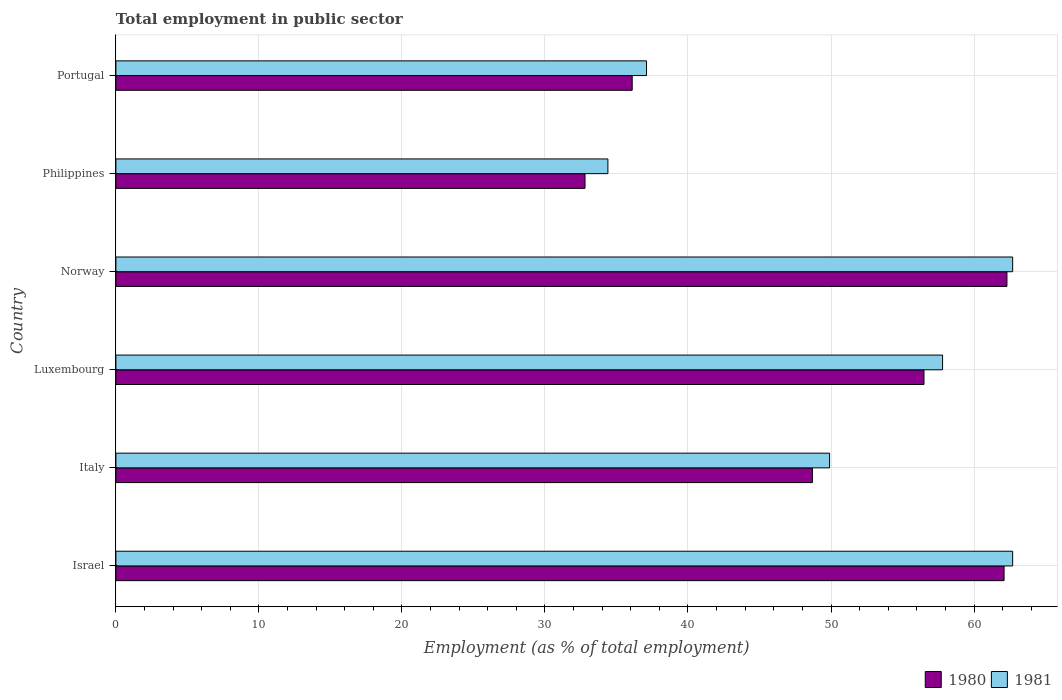Are the number of bars per tick equal to the number of legend labels?
Ensure brevity in your answer.  Yes. Are the number of bars on each tick of the Y-axis equal?
Provide a short and direct response. Yes. How many bars are there on the 5th tick from the bottom?
Give a very brief answer. 2. What is the label of the 3rd group of bars from the top?
Provide a succinct answer. Norway. In how many cases, is the number of bars for a given country not equal to the number of legend labels?
Your answer should be very brief. 0. What is the employment in public sector in 1981 in Norway?
Make the answer very short. 62.7. Across all countries, what is the maximum employment in public sector in 1981?
Your answer should be very brief. 62.7. Across all countries, what is the minimum employment in public sector in 1981?
Offer a terse response. 34.4. In which country was the employment in public sector in 1981 minimum?
Provide a short and direct response. Philippines. What is the total employment in public sector in 1980 in the graph?
Offer a terse response. 298.5. What is the difference between the employment in public sector in 1980 in Israel and that in Norway?
Make the answer very short. -0.2. What is the difference between the employment in public sector in 1981 in Portugal and the employment in public sector in 1980 in Philippines?
Provide a short and direct response. 4.3. What is the average employment in public sector in 1980 per country?
Provide a succinct answer. 49.75. What is the difference between the employment in public sector in 1981 and employment in public sector in 1980 in Luxembourg?
Your answer should be very brief. 1.3. In how many countries, is the employment in public sector in 1981 greater than 14 %?
Your response must be concise. 6. What is the ratio of the employment in public sector in 1981 in Luxembourg to that in Norway?
Provide a short and direct response. 0.92. What is the difference between the highest and the lowest employment in public sector in 1981?
Ensure brevity in your answer.  28.3. In how many countries, is the employment in public sector in 1981 greater than the average employment in public sector in 1981 taken over all countries?
Keep it short and to the point. 3. What does the 2nd bar from the top in Portugal represents?
Provide a short and direct response. 1980. How many countries are there in the graph?
Offer a terse response. 6. Does the graph contain any zero values?
Ensure brevity in your answer.  No. How many legend labels are there?
Your response must be concise. 2. What is the title of the graph?
Offer a terse response. Total employment in public sector. Does "2006" appear as one of the legend labels in the graph?
Your response must be concise. No. What is the label or title of the X-axis?
Keep it short and to the point. Employment (as % of total employment). What is the Employment (as % of total employment) of 1980 in Israel?
Give a very brief answer. 62.1. What is the Employment (as % of total employment) in 1981 in Israel?
Provide a short and direct response. 62.7. What is the Employment (as % of total employment) of 1980 in Italy?
Your answer should be very brief. 48.7. What is the Employment (as % of total employment) of 1981 in Italy?
Keep it short and to the point. 49.9. What is the Employment (as % of total employment) in 1980 in Luxembourg?
Your answer should be compact. 56.5. What is the Employment (as % of total employment) of 1981 in Luxembourg?
Make the answer very short. 57.8. What is the Employment (as % of total employment) of 1980 in Norway?
Provide a short and direct response. 62.3. What is the Employment (as % of total employment) of 1981 in Norway?
Provide a short and direct response. 62.7. What is the Employment (as % of total employment) in 1980 in Philippines?
Keep it short and to the point. 32.8. What is the Employment (as % of total employment) in 1981 in Philippines?
Offer a very short reply. 34.4. What is the Employment (as % of total employment) of 1980 in Portugal?
Your response must be concise. 36.1. What is the Employment (as % of total employment) in 1981 in Portugal?
Your response must be concise. 37.1. Across all countries, what is the maximum Employment (as % of total employment) of 1980?
Offer a terse response. 62.3. Across all countries, what is the maximum Employment (as % of total employment) in 1981?
Your response must be concise. 62.7. Across all countries, what is the minimum Employment (as % of total employment) in 1980?
Give a very brief answer. 32.8. Across all countries, what is the minimum Employment (as % of total employment) in 1981?
Offer a very short reply. 34.4. What is the total Employment (as % of total employment) of 1980 in the graph?
Keep it short and to the point. 298.5. What is the total Employment (as % of total employment) in 1981 in the graph?
Provide a succinct answer. 304.6. What is the difference between the Employment (as % of total employment) of 1980 in Israel and that in Luxembourg?
Provide a succinct answer. 5.6. What is the difference between the Employment (as % of total employment) in 1980 in Israel and that in Norway?
Your response must be concise. -0.2. What is the difference between the Employment (as % of total employment) in 1980 in Israel and that in Philippines?
Ensure brevity in your answer.  29.3. What is the difference between the Employment (as % of total employment) in 1981 in Israel and that in Philippines?
Your answer should be very brief. 28.3. What is the difference between the Employment (as % of total employment) in 1980 in Israel and that in Portugal?
Make the answer very short. 26. What is the difference between the Employment (as % of total employment) of 1981 in Israel and that in Portugal?
Give a very brief answer. 25.6. What is the difference between the Employment (as % of total employment) in 1981 in Italy and that in Philippines?
Give a very brief answer. 15.5. What is the difference between the Employment (as % of total employment) in 1981 in Italy and that in Portugal?
Provide a succinct answer. 12.8. What is the difference between the Employment (as % of total employment) in 1980 in Luxembourg and that in Norway?
Provide a succinct answer. -5.8. What is the difference between the Employment (as % of total employment) of 1981 in Luxembourg and that in Norway?
Give a very brief answer. -4.9. What is the difference between the Employment (as % of total employment) of 1980 in Luxembourg and that in Philippines?
Your answer should be compact. 23.7. What is the difference between the Employment (as % of total employment) in 1981 in Luxembourg and that in Philippines?
Offer a very short reply. 23.4. What is the difference between the Employment (as % of total employment) of 1980 in Luxembourg and that in Portugal?
Ensure brevity in your answer.  20.4. What is the difference between the Employment (as % of total employment) of 1981 in Luxembourg and that in Portugal?
Make the answer very short. 20.7. What is the difference between the Employment (as % of total employment) in 1980 in Norway and that in Philippines?
Provide a short and direct response. 29.5. What is the difference between the Employment (as % of total employment) in 1981 in Norway and that in Philippines?
Your answer should be compact. 28.3. What is the difference between the Employment (as % of total employment) of 1980 in Norway and that in Portugal?
Your answer should be compact. 26.2. What is the difference between the Employment (as % of total employment) in 1981 in Norway and that in Portugal?
Provide a short and direct response. 25.6. What is the difference between the Employment (as % of total employment) of 1980 in Philippines and that in Portugal?
Offer a very short reply. -3.3. What is the difference between the Employment (as % of total employment) in 1980 in Israel and the Employment (as % of total employment) in 1981 in Italy?
Your answer should be very brief. 12.2. What is the difference between the Employment (as % of total employment) in 1980 in Israel and the Employment (as % of total employment) in 1981 in Luxembourg?
Give a very brief answer. 4.3. What is the difference between the Employment (as % of total employment) of 1980 in Israel and the Employment (as % of total employment) of 1981 in Norway?
Provide a short and direct response. -0.6. What is the difference between the Employment (as % of total employment) in 1980 in Israel and the Employment (as % of total employment) in 1981 in Philippines?
Offer a terse response. 27.7. What is the difference between the Employment (as % of total employment) in 1980 in Israel and the Employment (as % of total employment) in 1981 in Portugal?
Keep it short and to the point. 25. What is the difference between the Employment (as % of total employment) in 1980 in Italy and the Employment (as % of total employment) in 1981 in Luxembourg?
Provide a short and direct response. -9.1. What is the difference between the Employment (as % of total employment) of 1980 in Italy and the Employment (as % of total employment) of 1981 in Philippines?
Keep it short and to the point. 14.3. What is the difference between the Employment (as % of total employment) of 1980 in Italy and the Employment (as % of total employment) of 1981 in Portugal?
Provide a short and direct response. 11.6. What is the difference between the Employment (as % of total employment) of 1980 in Luxembourg and the Employment (as % of total employment) of 1981 in Philippines?
Your response must be concise. 22.1. What is the difference between the Employment (as % of total employment) in 1980 in Norway and the Employment (as % of total employment) in 1981 in Philippines?
Give a very brief answer. 27.9. What is the difference between the Employment (as % of total employment) of 1980 in Norway and the Employment (as % of total employment) of 1981 in Portugal?
Give a very brief answer. 25.2. What is the average Employment (as % of total employment) in 1980 per country?
Make the answer very short. 49.75. What is the average Employment (as % of total employment) in 1981 per country?
Provide a succinct answer. 50.77. What is the difference between the Employment (as % of total employment) of 1980 and Employment (as % of total employment) of 1981 in Israel?
Your answer should be compact. -0.6. What is the difference between the Employment (as % of total employment) of 1980 and Employment (as % of total employment) of 1981 in Norway?
Make the answer very short. -0.4. What is the difference between the Employment (as % of total employment) in 1980 and Employment (as % of total employment) in 1981 in Philippines?
Offer a terse response. -1.6. What is the ratio of the Employment (as % of total employment) of 1980 in Israel to that in Italy?
Your answer should be compact. 1.28. What is the ratio of the Employment (as % of total employment) of 1981 in Israel to that in Italy?
Your response must be concise. 1.26. What is the ratio of the Employment (as % of total employment) in 1980 in Israel to that in Luxembourg?
Give a very brief answer. 1.1. What is the ratio of the Employment (as % of total employment) of 1981 in Israel to that in Luxembourg?
Your answer should be compact. 1.08. What is the ratio of the Employment (as % of total employment) in 1980 in Israel to that in Norway?
Your response must be concise. 1. What is the ratio of the Employment (as % of total employment) in 1980 in Israel to that in Philippines?
Make the answer very short. 1.89. What is the ratio of the Employment (as % of total employment) in 1981 in Israel to that in Philippines?
Offer a very short reply. 1.82. What is the ratio of the Employment (as % of total employment) of 1980 in Israel to that in Portugal?
Make the answer very short. 1.72. What is the ratio of the Employment (as % of total employment) of 1981 in Israel to that in Portugal?
Your response must be concise. 1.69. What is the ratio of the Employment (as % of total employment) of 1980 in Italy to that in Luxembourg?
Ensure brevity in your answer.  0.86. What is the ratio of the Employment (as % of total employment) of 1981 in Italy to that in Luxembourg?
Provide a short and direct response. 0.86. What is the ratio of the Employment (as % of total employment) in 1980 in Italy to that in Norway?
Provide a short and direct response. 0.78. What is the ratio of the Employment (as % of total employment) in 1981 in Italy to that in Norway?
Your answer should be very brief. 0.8. What is the ratio of the Employment (as % of total employment) in 1980 in Italy to that in Philippines?
Your response must be concise. 1.48. What is the ratio of the Employment (as % of total employment) of 1981 in Italy to that in Philippines?
Make the answer very short. 1.45. What is the ratio of the Employment (as % of total employment) in 1980 in Italy to that in Portugal?
Keep it short and to the point. 1.35. What is the ratio of the Employment (as % of total employment) in 1981 in Italy to that in Portugal?
Ensure brevity in your answer.  1.34. What is the ratio of the Employment (as % of total employment) in 1980 in Luxembourg to that in Norway?
Your answer should be compact. 0.91. What is the ratio of the Employment (as % of total employment) of 1981 in Luxembourg to that in Norway?
Your answer should be compact. 0.92. What is the ratio of the Employment (as % of total employment) in 1980 in Luxembourg to that in Philippines?
Offer a terse response. 1.72. What is the ratio of the Employment (as % of total employment) of 1981 in Luxembourg to that in Philippines?
Your answer should be very brief. 1.68. What is the ratio of the Employment (as % of total employment) in 1980 in Luxembourg to that in Portugal?
Your response must be concise. 1.57. What is the ratio of the Employment (as % of total employment) of 1981 in Luxembourg to that in Portugal?
Ensure brevity in your answer.  1.56. What is the ratio of the Employment (as % of total employment) of 1980 in Norway to that in Philippines?
Your answer should be very brief. 1.9. What is the ratio of the Employment (as % of total employment) of 1981 in Norway to that in Philippines?
Your answer should be very brief. 1.82. What is the ratio of the Employment (as % of total employment) in 1980 in Norway to that in Portugal?
Your response must be concise. 1.73. What is the ratio of the Employment (as % of total employment) of 1981 in Norway to that in Portugal?
Your answer should be very brief. 1.69. What is the ratio of the Employment (as % of total employment) in 1980 in Philippines to that in Portugal?
Give a very brief answer. 0.91. What is the ratio of the Employment (as % of total employment) of 1981 in Philippines to that in Portugal?
Ensure brevity in your answer.  0.93. What is the difference between the highest and the second highest Employment (as % of total employment) of 1981?
Your answer should be compact. 0. What is the difference between the highest and the lowest Employment (as % of total employment) of 1980?
Offer a terse response. 29.5. What is the difference between the highest and the lowest Employment (as % of total employment) in 1981?
Your response must be concise. 28.3. 